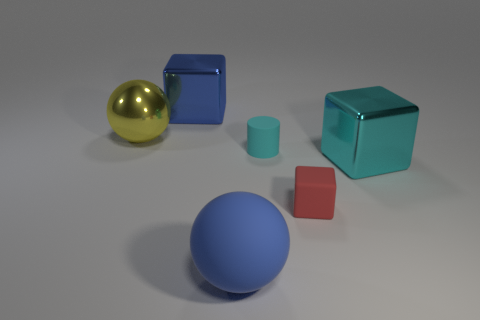How many blue matte spheres are the same size as the cylinder?
Keep it short and to the point. 0. There is a big object that is both behind the tiny cyan cylinder and on the right side of the large yellow ball; what color is it?
Offer a very short reply. Blue. Are there fewer large yellow metallic balls than large purple rubber cylinders?
Ensure brevity in your answer.  No. Do the large shiny sphere and the matte thing behind the big cyan block have the same color?
Make the answer very short. No. Is the number of yellow things that are right of the yellow thing the same as the number of cyan matte cylinders to the left of the small cyan thing?
Give a very brief answer. Yes. What number of other metallic things are the same shape as the cyan metal object?
Offer a terse response. 1. Are there any big blue metal cylinders?
Offer a terse response. No. Is the large yellow sphere made of the same material as the blue object behind the rubber block?
Your answer should be compact. Yes. What material is the cyan object that is the same size as the yellow ball?
Give a very brief answer. Metal. Is there a large blue cube that has the same material as the small cyan thing?
Keep it short and to the point. No. 